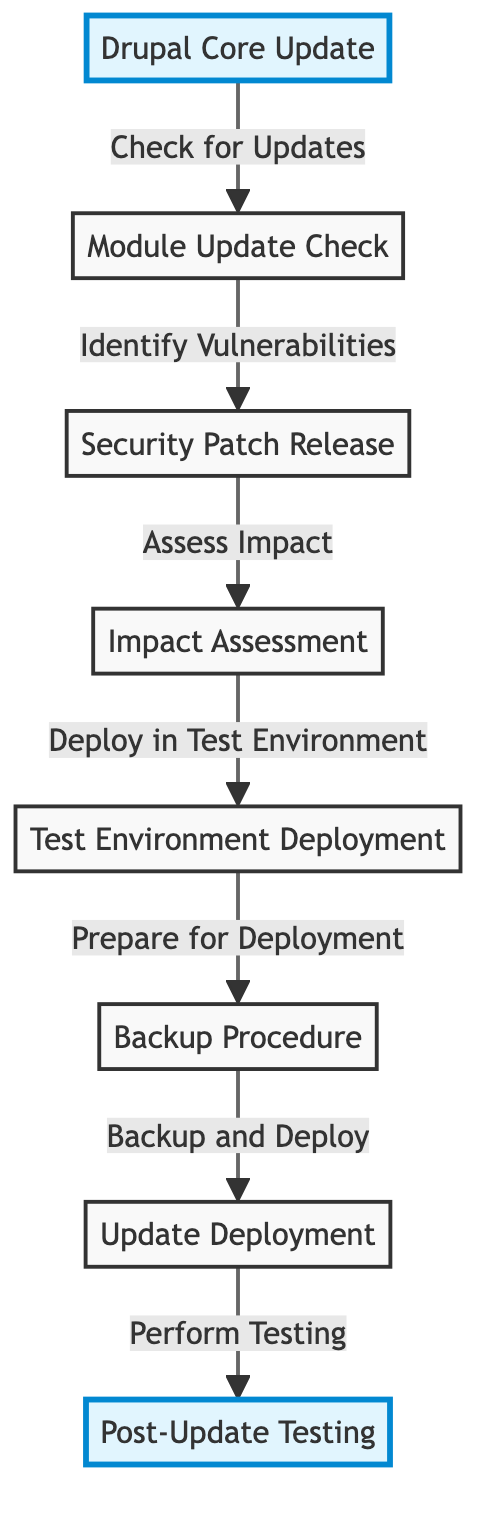What is the first step in the update process? The first step is labeled "Drupal Core Update" which indicates that this is the starting point for the update process, where the system checks for updates.
Answer: Drupal Core Update How many processes are outlined in the diagram? Counting each node, there are a total of 7 processes included in the diagram that detail the update and security patch timeline.
Answer: 7 Which node follows "Impact Assessment"? The node that follows "Impact Assessment" is "Test Environment Deployment", indicating that after assessing the impact, the process proceeds to deployment in a test environment.
Answer: Test Environment Deployment What action is performed after "Update Deployment"? The action performed after "Update Deployment" is "Post-Update Testing", which is the final step to ensure the update is successful and doesn't introduce issues.
Answer: Post-Update Testing What is the relationship between "Module Update Check" and "Security Patch Release"? The relationship is such that "Module Update Check" leads to "Security Patch Release" as it identifies vulnerabilities that must be addressed.
Answer: Identify Vulnerabilities What is the last node in the update timeline? The last node in the update timeline is "Post-Update Testing", which signifies the end of the process where testing occurs to confirm everything is functioning correctly.
Answer: Post-Update Testing Which action must take place before "Update Deployment"? Before "Update Deployment", the "Backup Procedure" must be completed, indicating that a backup of the existing system should be made prior to deploying any updates.
Answer: Backup Procedure What action takes place after checking for updates? After checking for updates, the action that takes place is "Module Update Check", which specifically looks for module updates and potential vulnerabilities.
Answer: Module Update Check What color is used to highlight the start and end of the process? The nodes representing "Drupal Core Update" and "Post-Update Testing" are both highlighted in a light blue color, indicating their significance as the start and end of the process.
Answer: Light blue 